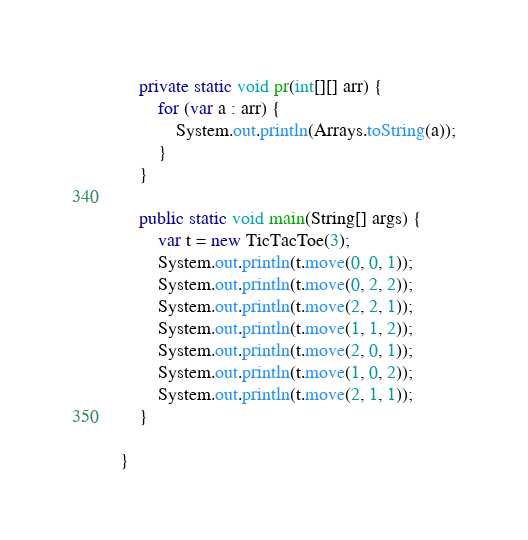Convert code to text. <code><loc_0><loc_0><loc_500><loc_500><_Java_>
    private static void pr(int[][] arr) {
        for (var a : arr) {
            System.out.println(Arrays.toString(a));
        }
    }

    public static void main(String[] args) {
        var t = new TicTacToe(3);
        System.out.println(t.move(0, 0, 1));
        System.out.println(t.move(0, 2, 2));
        System.out.println(t.move(2, 2, 1));
        System.out.println(t.move(1, 1, 2));
        System.out.println(t.move(2, 0, 1));
        System.out.println(t.move(1, 0, 2));
        System.out.println(t.move(2, 1, 1));
    }

}
</code> 